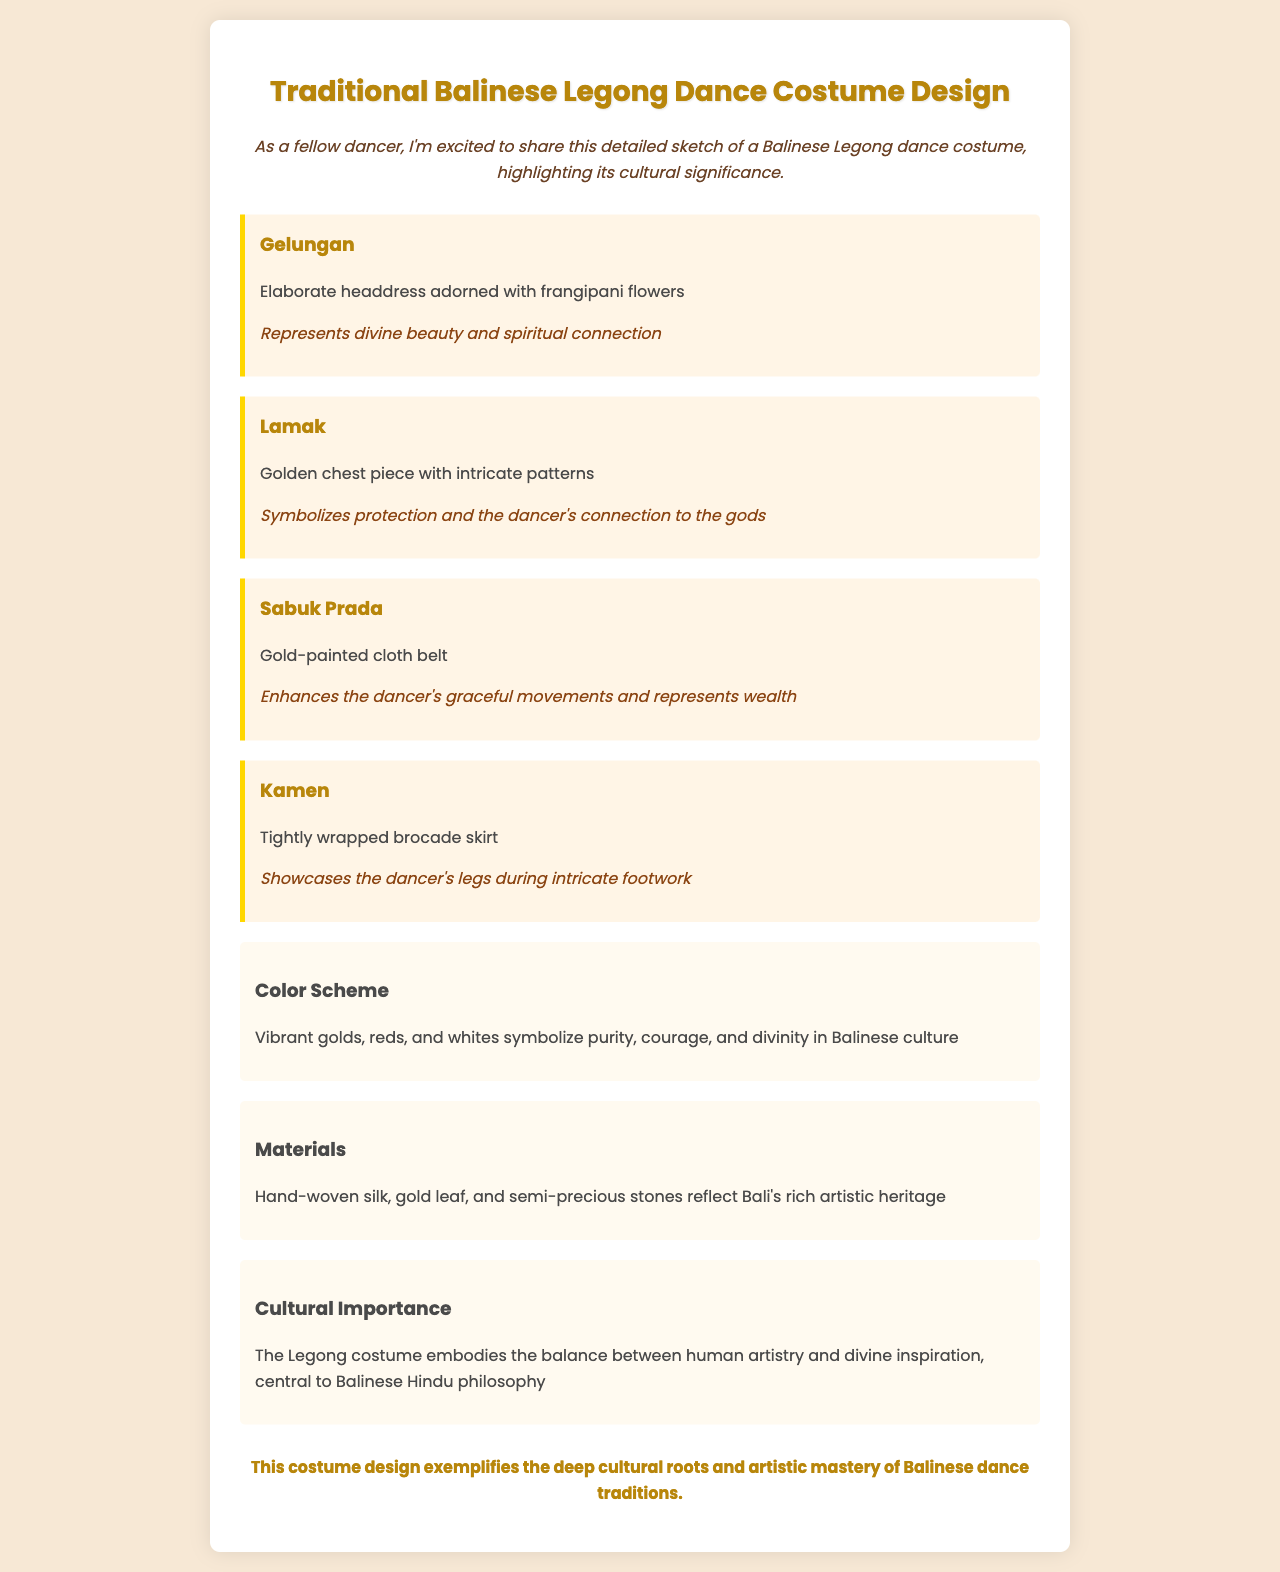What is the name of the traditional dance discussed? The document specifically describes the Balinese Legong dance costume design.
Answer: Balinese Legong What does the Gelungan represent? The Gelungan is an elaborate headdress that symbolizes divine beauty and spiritual connection.
Answer: Divine beauty and spiritual connection What materials are used in the costume design? The document mentions hand-woven silk, gold leaf, and semi-precious stones as materials, reflecting Bali's artisanal heritage.
Answer: Hand-woven silk, gold leaf, and semi-precious stones What does the Kamen showcase? The Kamen, a tightly wrapped brocade skirt, is designed to showcase the dancer's legs during footwork movements.
Answer: Dancer's legs What colors are prominent in the costume's color scheme? The color scheme mentions vibrant golds, reds, and whites that symbolize purity, courage, and divinity.
Answer: Gold, red, white How does the Lamak function in the dance? The Lamak is a golden chest piece that symbolizes protection and the dancer's connection to the gods, enhancing their presence.
Answer: Protection and connection to the gods What embodies the balance in Balinese dance traditions according to the document? The cultural importance section states that the Legong costume embodies the balance between human artistry and divine inspiration.
Answer: Human artistry and divine inspiration What flower adorns the Gelungan? The Gelungan is adorned with frangipani flowers as part of its elaborate design.
Answer: Frangipani flowers What is the document type? The structured format and content of this document suggest that it is a detailed sketch in the form of a fax discussing a costume design.
Answer: Fax 